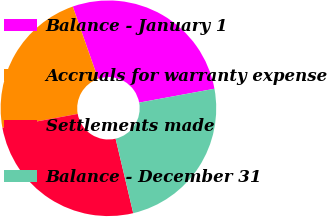Convert chart to OTSL. <chart><loc_0><loc_0><loc_500><loc_500><pie_chart><fcel>Balance - January 1<fcel>Accruals for warranty expense<fcel>Settlements made<fcel>Balance - December 31<nl><fcel>27.47%<fcel>22.53%<fcel>25.8%<fcel>24.2%<nl></chart> 